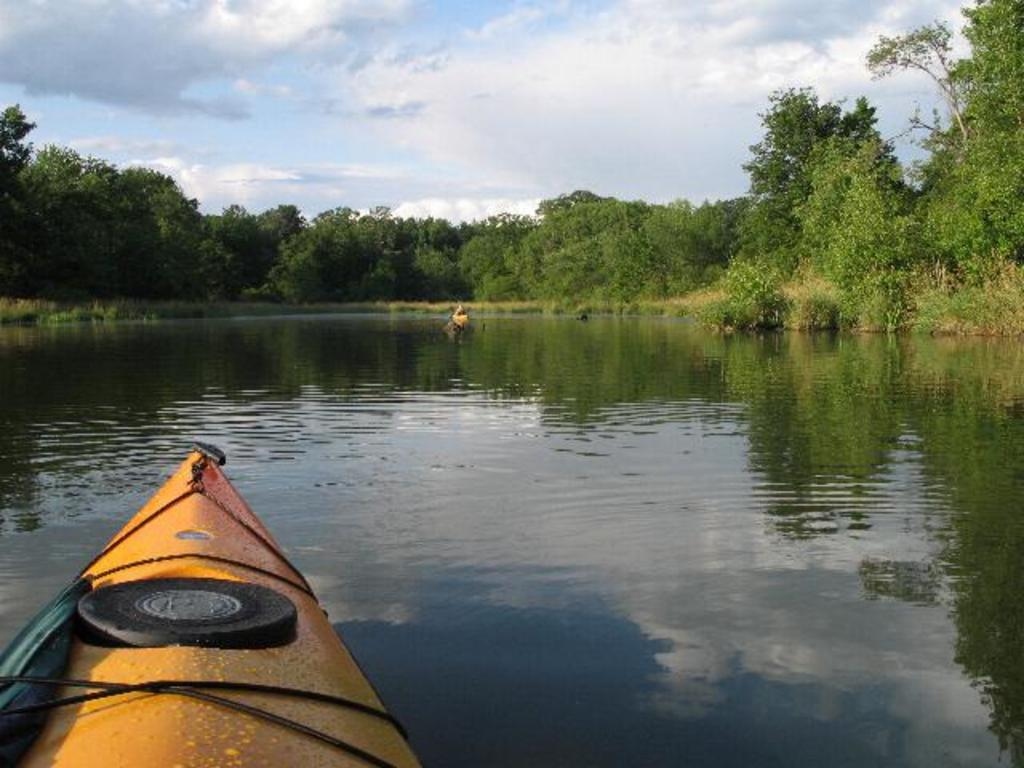How many birds are in the image? There are two birds in the image. Where are the birds located? The birds are on the water in the image. What else can be seen on the water? Boats are visible in the image. What type of vegetation is present in the image? Trees are visible in the image. How would you describe the weather in the image? The sky is cloudy in the image. What type of test can be seen being conducted on the birds in the image? There is no test being conducted on the birds in the image; they are simply on the water. What thrilling activity are the birds participating in the image? There is no thrilling activity being depicted in the image; the birds are simply on the water. 